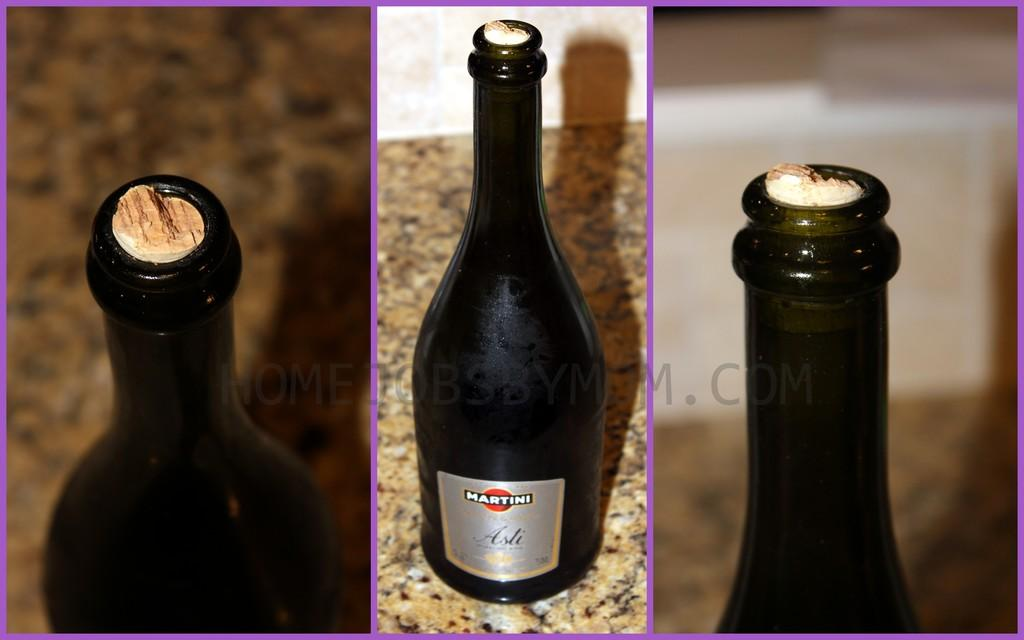What type of image is being described? The image is a collage. What objects can be seen in the collage? There are bottles in the image. How would you describe the background of the collage? The background of the image is blurry. What language is being spoken by the bottles in the image? There is no indication that the bottles are speaking any language in the image. 